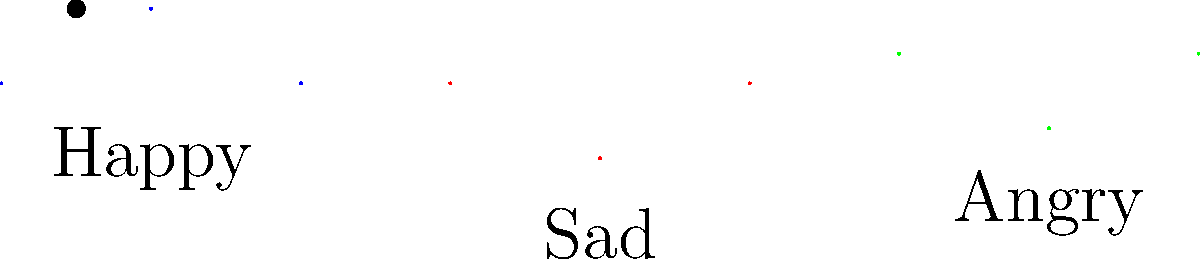In a new Disney+ series featuring classic characters, an AI is being developed to detect emotions in facial expressions. Given the simplified representation of three emotions above, which mathematical function would best model the "Happy" expression for machine learning purposes? To determine the best mathematical function to model the "Happy" expression, let's analyze the graph step-by-step:

1. The "Happy" expression is represented by a curve that starts at (0,0), peaks at (1,0.5), and ends at (2,0).

2. This curve resembles a parabola, which can be described by a quadratic function.

3. The general form of a quadratic function is:
   $$f(x) = ax^2 + bx + c$$

4. We can determine the coefficients a, b, and c using the three points:
   (0,0), (1,0.5), and (2,0)

5. Substituting these points into the general form:
   (0,0): $c = 0$
   (1,0.5): $a + b = 0.5$
   (2,0): $4a + 2b = 0$

6. Solving this system of equations:
   $4a + 2b = 0$
   $a + b = 0.5$
   
   Subtracting the second equation from the first:
   $3a + b = -0.5$
   $a + b = 0.5$
   
   Subtracting again:
   $2a = -1$
   $a = -0.5$
   
   Substituting back:
   $-0.5 + b = 0.5$
   $b = 1$

7. Therefore, the quadratic function that best models the "Happy" expression is:
   $$f(x) = -0.5x^2 + x$$

This function creates a parabola that opens downward, reaches its peak at x=1, and passes through (0,0) and (2,0), matching the "Happy" curve in the graph.
Answer: $$f(x) = -0.5x^2 + x$$ 